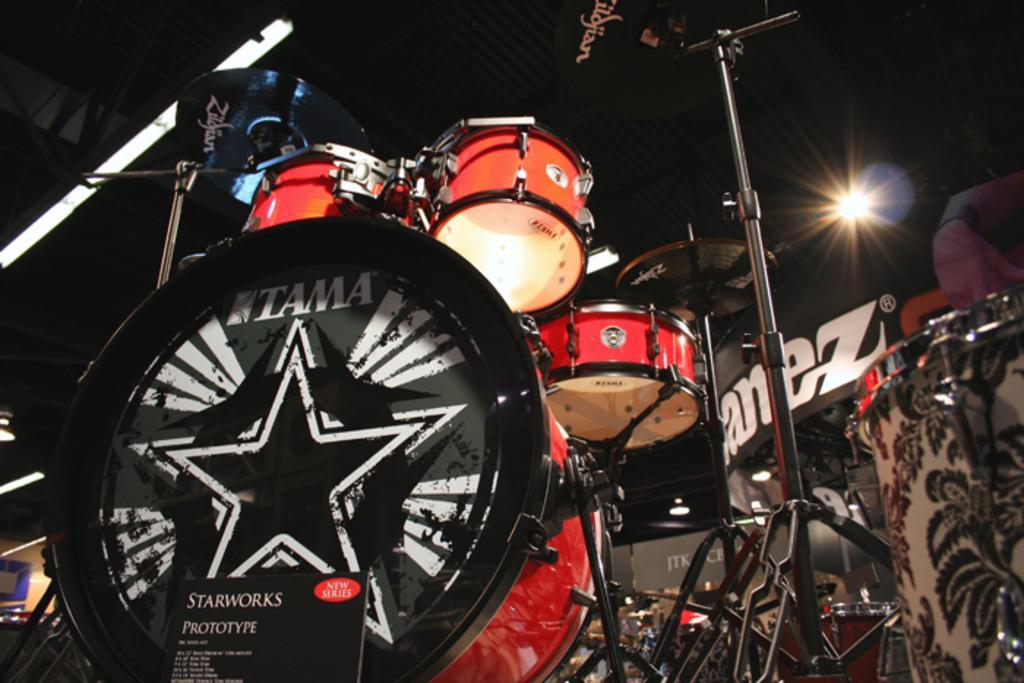Please provide a concise description of this image. In this image there are musical instruments, rods, mic stand, boards, lights and objects. In the background of the image it is dark. On the right side of the image there is a person's hand.   